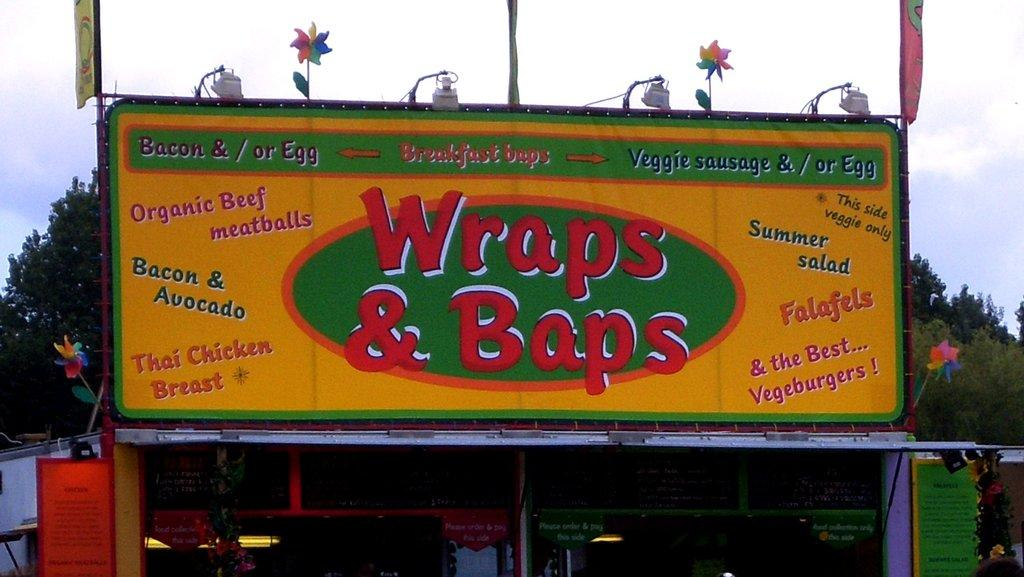<image>
Write a terse but informative summary of the picture. An open air shop with a large sign that says Wraps & Baps. 